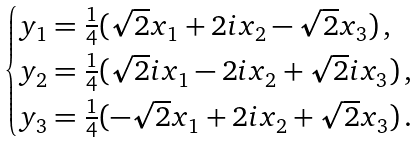<formula> <loc_0><loc_0><loc_500><loc_500>\begin{cases} y _ { 1 } = \frac { 1 } { 4 } ( \sqrt { 2 } x _ { 1 } + 2 i x _ { 2 } - \sqrt { 2 } x _ { 3 } ) \, , \\ y _ { 2 } = \frac { 1 } { 4 } ( \sqrt { 2 } i x _ { 1 } - 2 i x _ { 2 } + \sqrt { 2 } i x _ { 3 } ) \, , \\ y _ { 3 } = \frac { 1 } { 4 } ( - \sqrt { 2 } x _ { 1 } + 2 i x _ { 2 } + \sqrt { 2 } x _ { 3 } ) \, . \end{cases}</formula> 